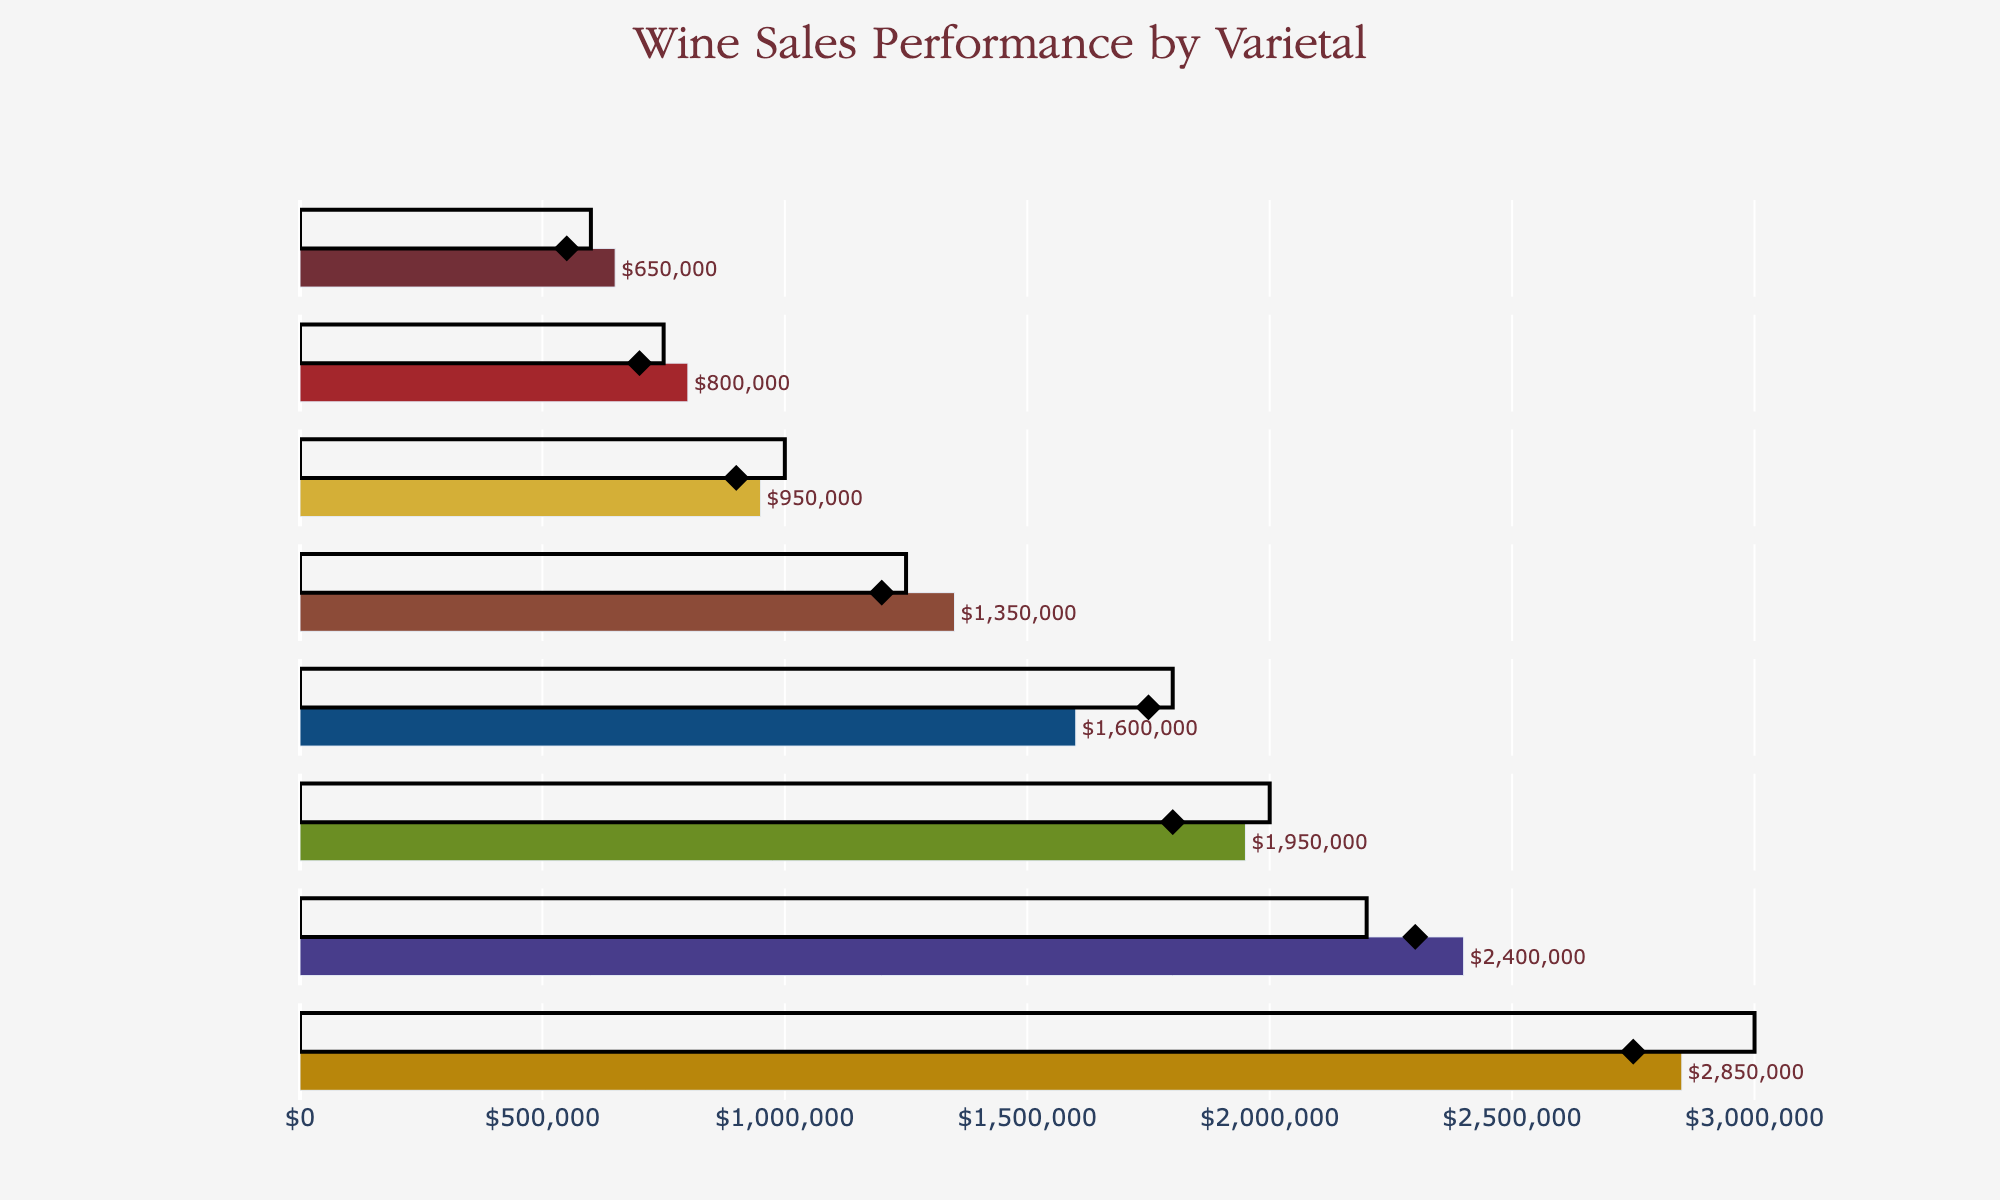What's the title of the chart? The title is located at the top of the chart and reads, "Wine Sales Performance by Varietal."
Answer: Wine Sales Performance by Varietal Which varietal had the highest actual sales? To determine this, find the varietal with the longest bar in the horizontal bar chart. Cabernet Sauvignon has the longest bar, indicating the highest actual sales.
Answer: Cabernet Sauvignon What is the target sales value for Pinot Noir? Look at the light-colored bar (or highlighted target line) aligned with Pinot Noir and read the associated value. The target sales for Pinot Noir is $2,000,000.
Answer: $2,000,000 How did Merlot's actual sales compare to its target? Find Merlot and note the length of the actual sales bar relative to the target line. Merlot's actual sales are lower than its target.
Answer: Lower than the target Which varietal surpassed its target sales? Identify the varietal(s) where the actual sales bar exceeds the target line. Chardonnay is the varietal that surpassed its target sales.
Answer: Chardonnay What's the difference in actual sales between Zinfandel and Riesling? Subtract the actual sales amount of Riesling from that of Zinfandel: $800,000 - $650,000 = $150,000.
Answer: $150,000 How do Riesling's actual sales compare to the previous year's sales? Look at the actual sales bar and the black diamond marker for Riesling. The actual sales bar is higher than the previous year's sales marker.
Answer: Higher than previous year Which varietal had the lowest target sales? Locate the shortest target indicator across all varietals. Riesling has the lowest target sales at $600,000.
Answer: Riesling If Syrah hit its target sales, how much more would it have earned compared to its actual sales? Subtract Syrah's actual sales from its target sales: $1,000,000 - $950,000 = $50,000.
Answer: $50,000 What is the combined total of Chardonnay's and Zinfandel's actual sales? Add the actual sales amounts of Chardonnay and Zinfandel: $2,400,000 + $800,000 = $3,200,000.
Answer: $3,200,000 